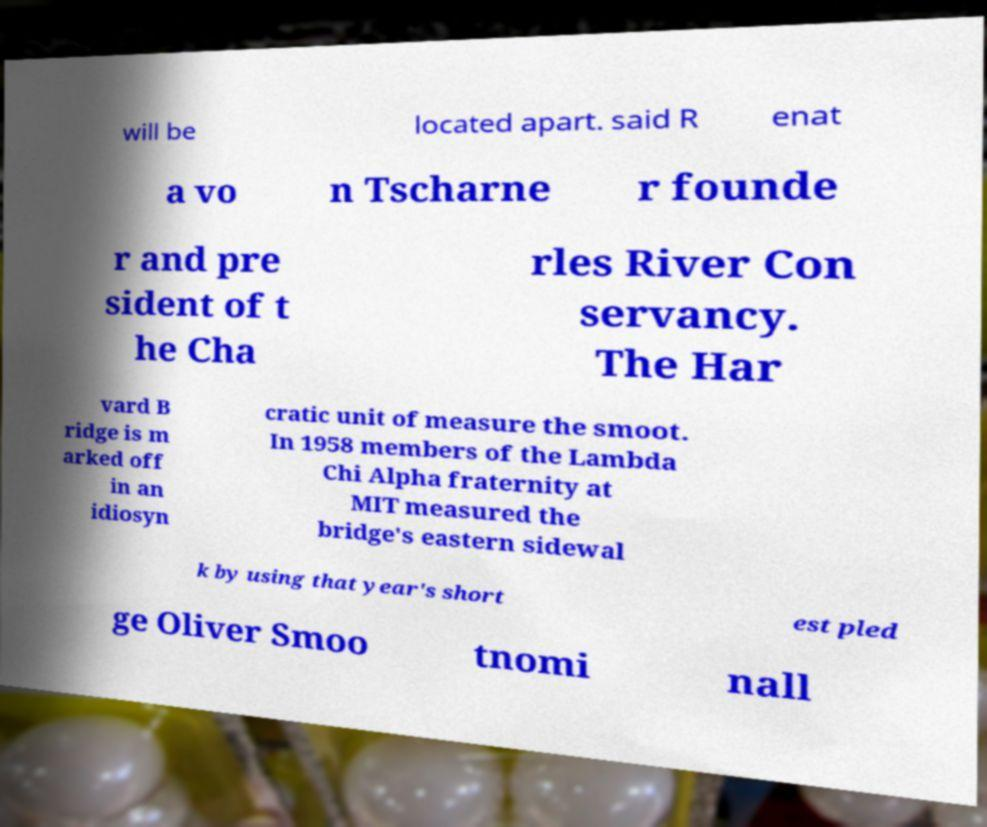Can you accurately transcribe the text from the provided image for me? will be located apart. said R enat a vo n Tscharne r founde r and pre sident of t he Cha rles River Con servancy. The Har vard B ridge is m arked off in an idiosyn cratic unit of measure the smoot. In 1958 members of the Lambda Chi Alpha fraternity at MIT measured the bridge's eastern sidewal k by using that year's short est pled ge Oliver Smoo tnomi nall 